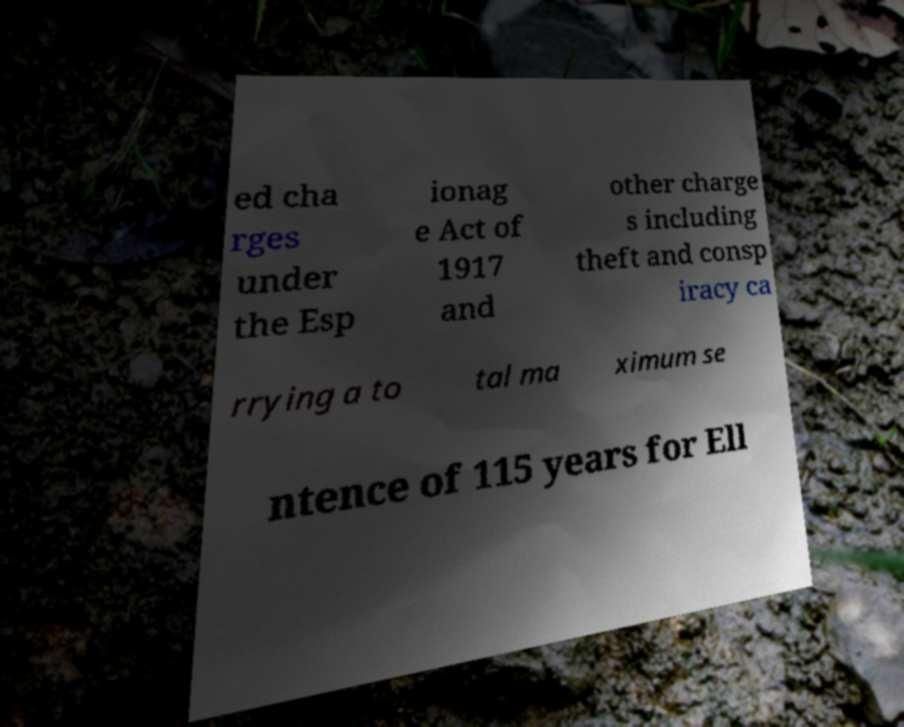For documentation purposes, I need the text within this image transcribed. Could you provide that? ed cha rges under the Esp ionag e Act of 1917 and other charge s including theft and consp iracy ca rrying a to tal ma ximum se ntence of 115 years for Ell 